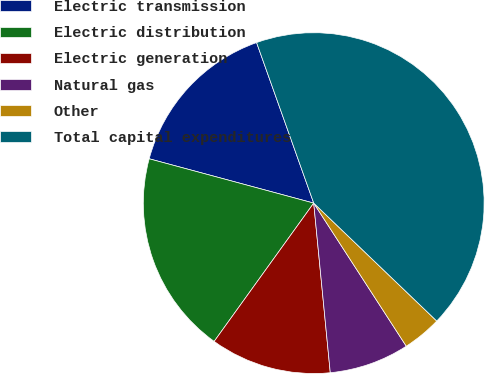Convert chart. <chart><loc_0><loc_0><loc_500><loc_500><pie_chart><fcel>Electric transmission<fcel>Electric distribution<fcel>Electric generation<fcel>Natural gas<fcel>Other<fcel>Total capital expenditures<nl><fcel>15.37%<fcel>19.26%<fcel>11.48%<fcel>7.59%<fcel>3.7%<fcel>42.61%<nl></chart> 